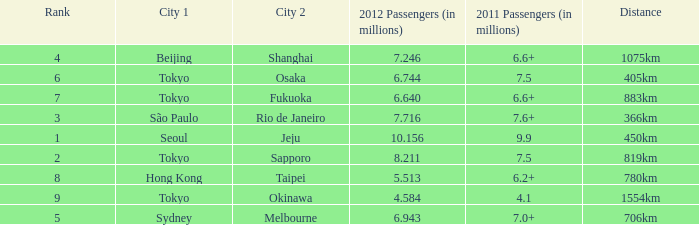What the is the first city listed on the route that had 6.6+ passengers in 2011 and a distance of 1075km? Beijing. 